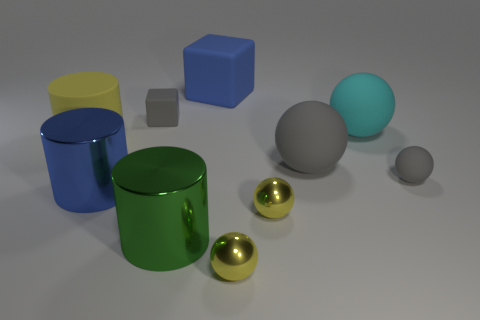How many small spheres are the same color as the large rubber cylinder?
Give a very brief answer. 2. How many things are big matte objects in front of the blue rubber cube or objects that are in front of the blue cube?
Provide a short and direct response. 9. There is a big thing that is behind the big cyan matte object; how many objects are in front of it?
Offer a very short reply. 9. The large thing that is the same material as the big green cylinder is what color?
Offer a very short reply. Blue. Are there any other matte balls that have the same size as the cyan sphere?
Provide a succinct answer. Yes. What shape is the blue rubber thing that is the same size as the cyan matte object?
Offer a very short reply. Cube. Is there another green shiny thing that has the same shape as the green thing?
Provide a succinct answer. No. Is the large cyan object made of the same material as the gray sphere that is to the left of the tiny rubber sphere?
Offer a terse response. Yes. Is there a thing of the same color as the large matte cube?
Ensure brevity in your answer.  Yes. What number of other objects are the same material as the tiny cube?
Make the answer very short. 5. 